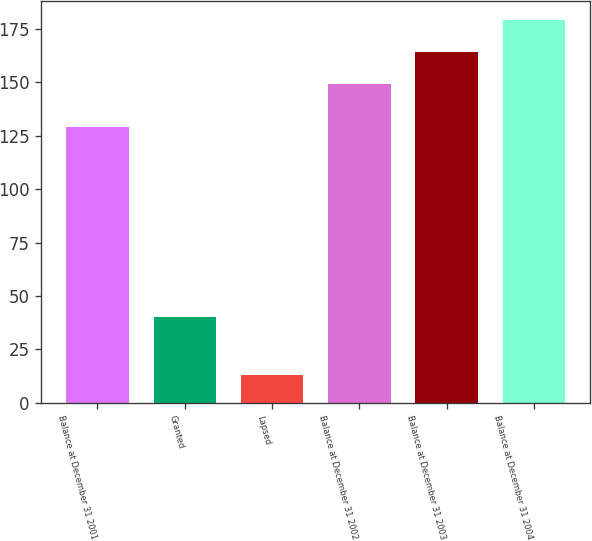Convert chart to OTSL. <chart><loc_0><loc_0><loc_500><loc_500><bar_chart><fcel>Balance at December 31 2001<fcel>Granted<fcel>Lapsed<fcel>Balance at December 31 2002<fcel>Balance at December 31 2003<fcel>Balance at December 31 2004<nl><fcel>129<fcel>40<fcel>13<fcel>149<fcel>164<fcel>179<nl></chart> 